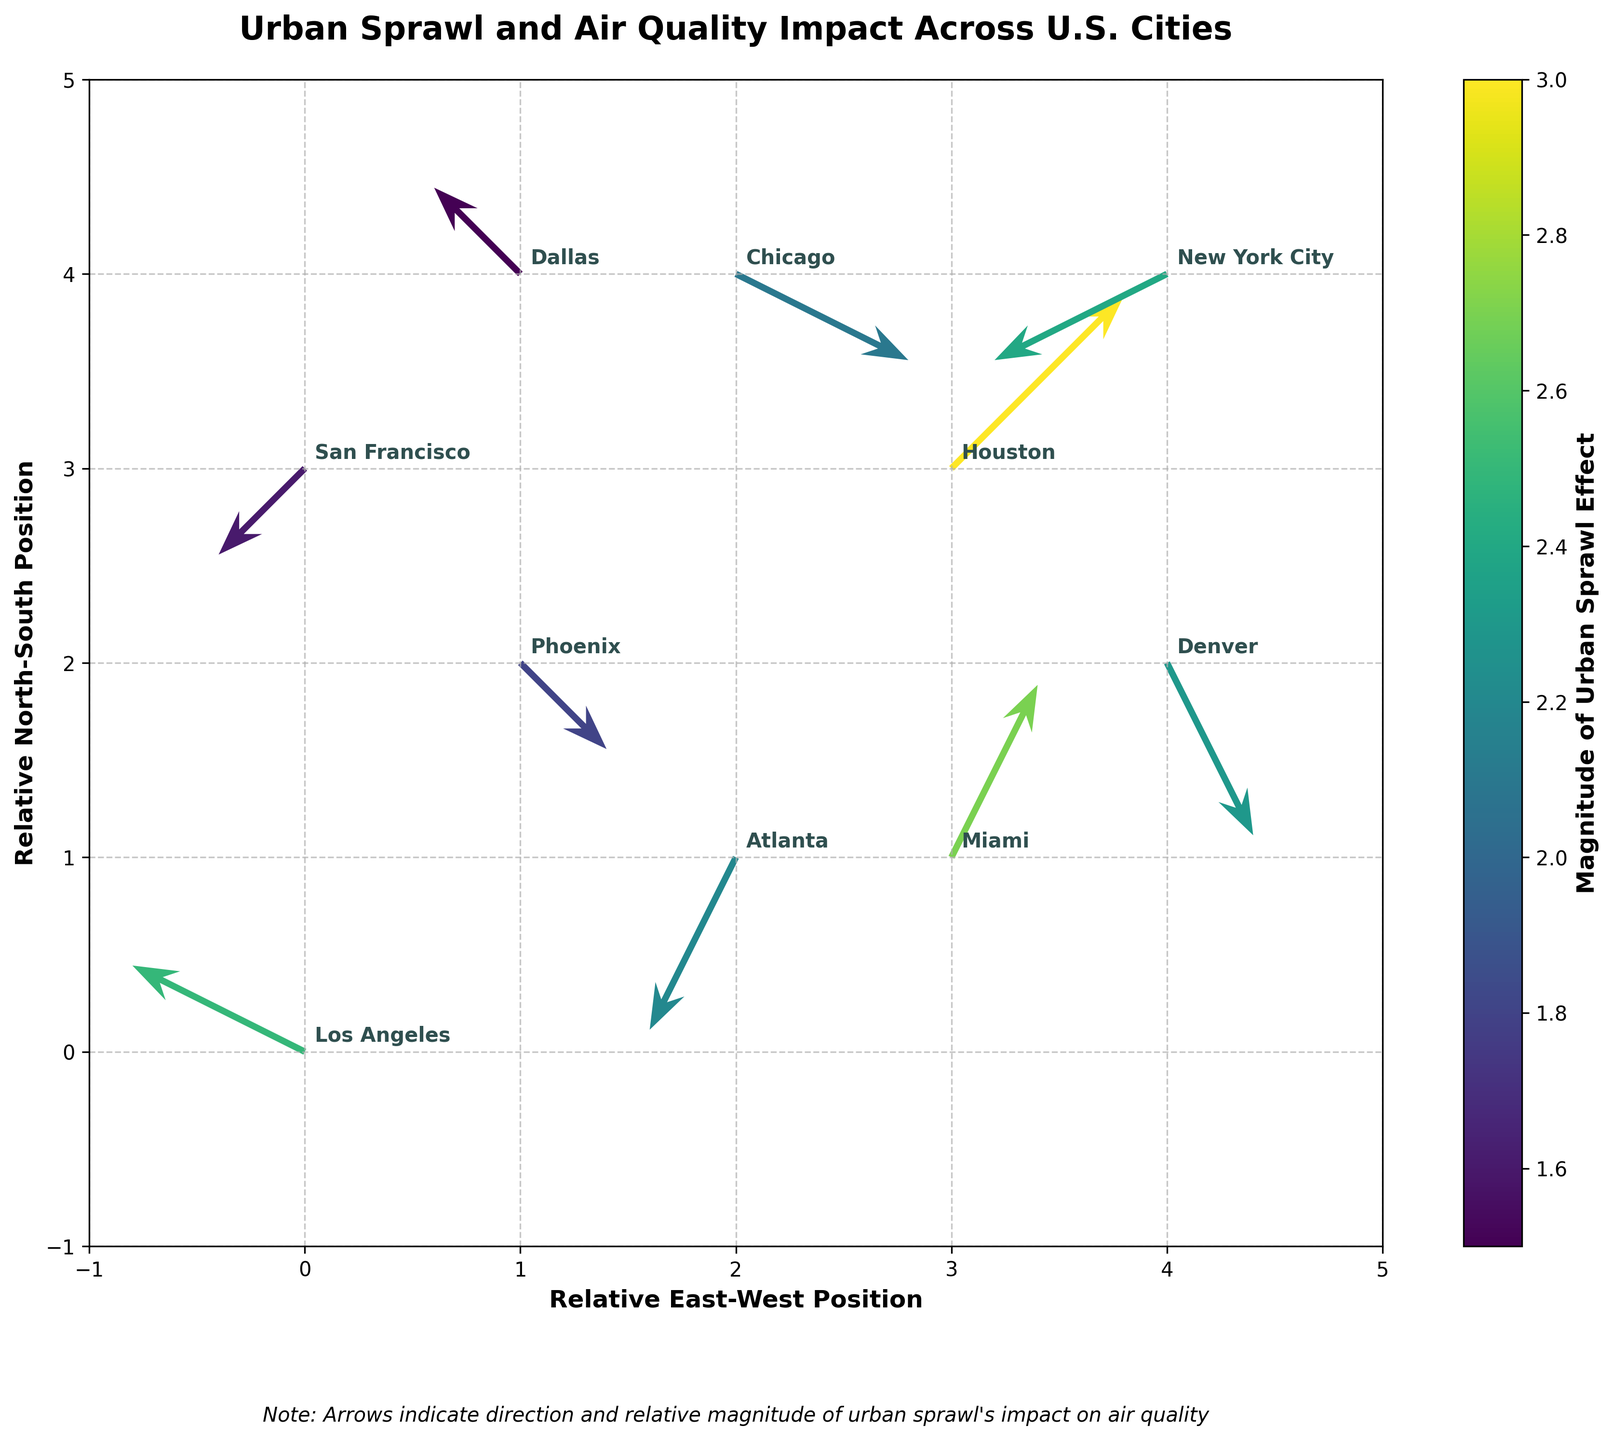What is the title of the plot? The title of the plot is displayed at the top, above the plot area. It reads "Urban Sprawl and Air Quality Impact Across U.S. Cities".
Answer: Urban Sprawl and Air Quality Impact Across U.S. Cities What function does the colorbar serve in the plot? The colorbar, located to the right of the plot, indicates the magnitude of the impact of urban sprawl on air quality. It uses varying colors to represent different magnitudes.
Answer: Indicates magnitude of impact How many cities are represented in the plot? Each arrow corresponds to a city, and each city has a label. Counting these labels, there are 10 cities represented in the plot.
Answer: 10 cities Which city has the highest magnitude of impact? The color coding on the arrows, combined with the city annotations, shows that Houston has the highest magnitude of 3.0, represented by the brightest color.
Answer: Houston What is the effect direction of urban sprawl on air quality for New York City? The direction of the arrow representing New York City indicates the effect. The arrow points leftward and downward, indicating a westward and southward effect.
Answer: Westward and southward How are the arrows for Phoenix and Miami different in terms of orientation? The arrow for Phoenix points southeast (right and down), while the arrow for Miami points northeast (right and up), indicating differing impacts on air quality.
Answer: Phoenix: southeast, Miami: northeast Which city sees a greater net effect of urban sprawl on air quality, Atlanta or New York City? We sum the magnitudes of the u and v components for each city. For Atlanta, the net effect is sqrt((-1)^2 + (-2)^2) ≈ 2.2. For New York City, it is sqrt((-2)^2 + (-1)^2) ≈ 2.4. New York City has a slightly greater net effect.
Answer: New York City Does any city experience a predominantly northward impact? By examining the orientation of the arrows, we see that Miami's arrow points predominantly northward (upward).
Answer: Miami What is the direction and magnitude of the effect for Dallas? The arrow for Dallas points towards the northwest (left and up) with a smaller magnitude. The magnitude from the color bar indicates a value of 1.5.
Answer: Northwest, 1.5 Which city shows the least impact from urban sprawl on air quality? The color indicates the magnitude of the impact. Dallas shows the smallest magnitude of 1.5, confirmed by the color bar.
Answer: Dallas 